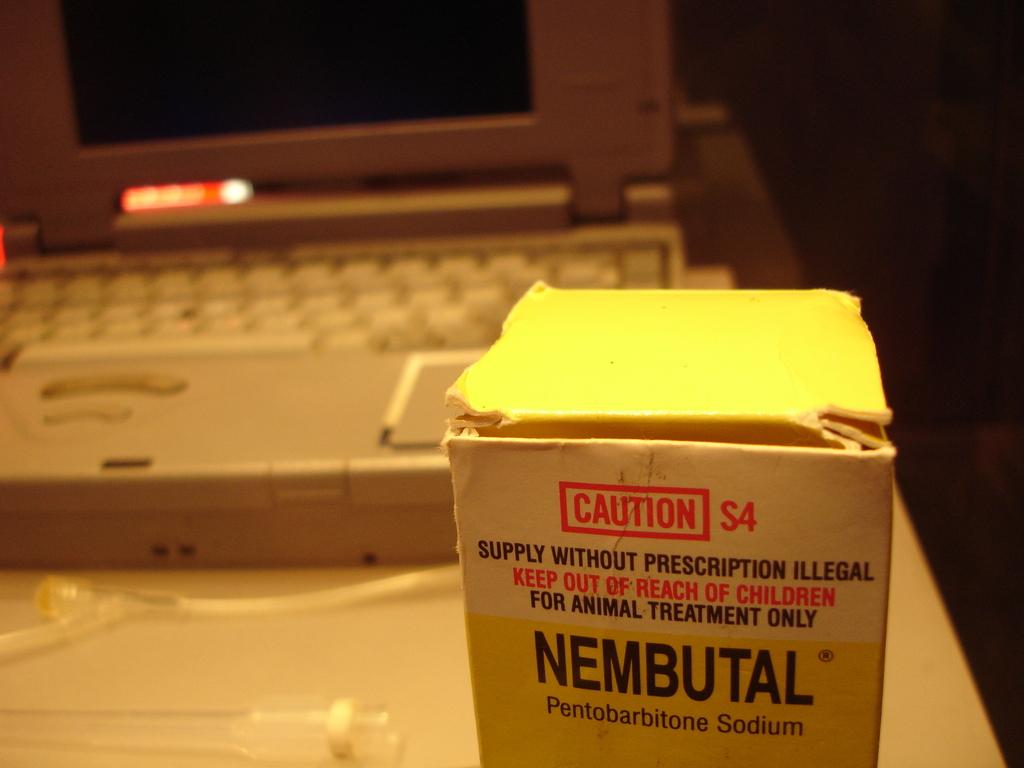Who should be kept away from this product?
Ensure brevity in your answer.  Children. What is the name of this product?
Make the answer very short. Nembutal. 